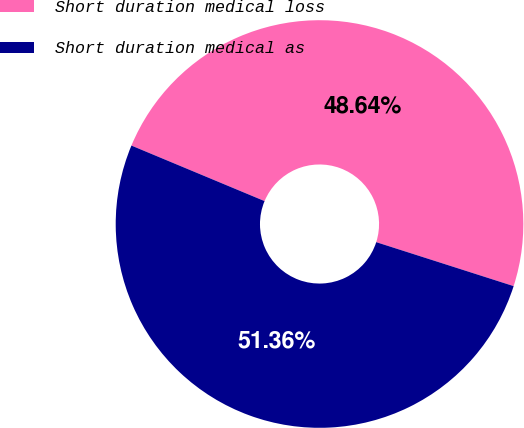Convert chart to OTSL. <chart><loc_0><loc_0><loc_500><loc_500><pie_chart><fcel>Short duration medical loss<fcel>Short duration medical as<nl><fcel>48.64%<fcel>51.36%<nl></chart> 